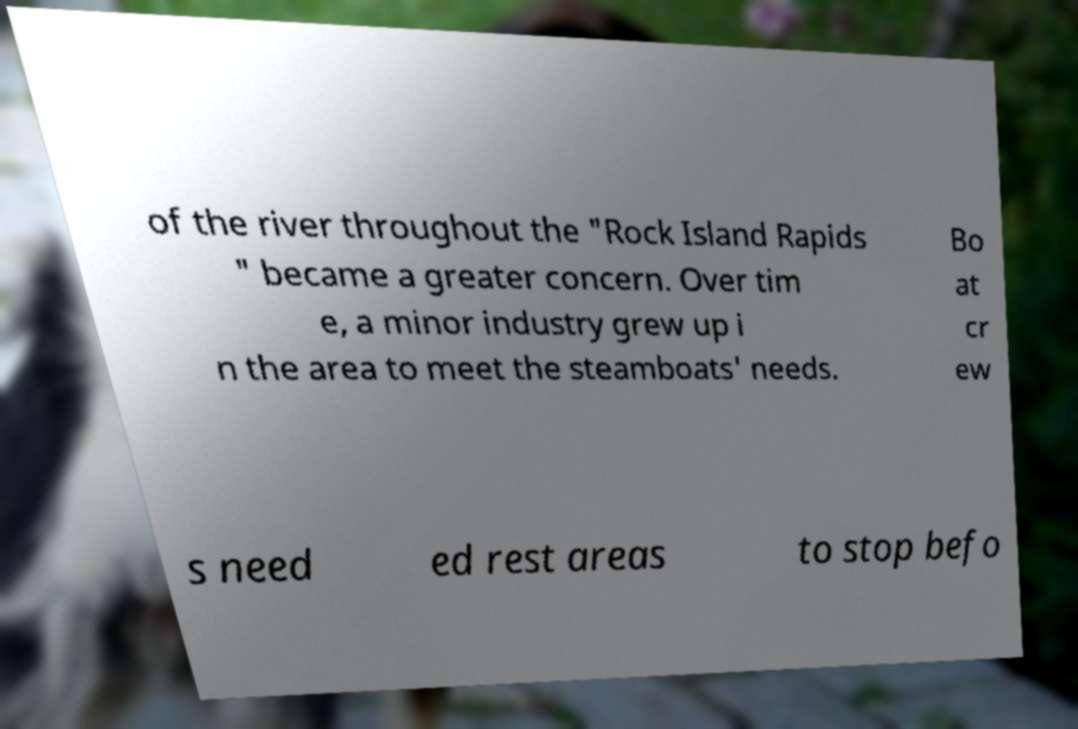There's text embedded in this image that I need extracted. Can you transcribe it verbatim? of the river throughout the "Rock Island Rapids " became a greater concern. Over tim e, a minor industry grew up i n the area to meet the steamboats' needs. Bo at cr ew s need ed rest areas to stop befo 